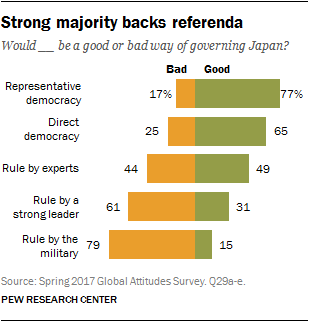Mention a couple of crucial points in this snapshot. The average value of all the leftmost bars in the graph is 45.2. The value of the smallest bar in the first set is 15. 